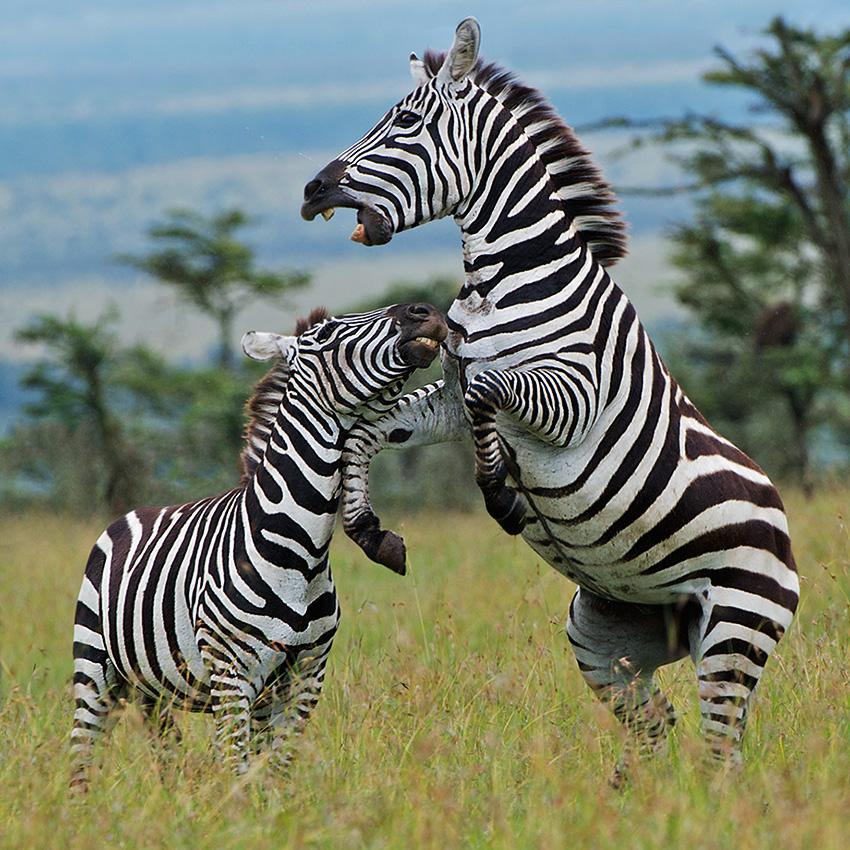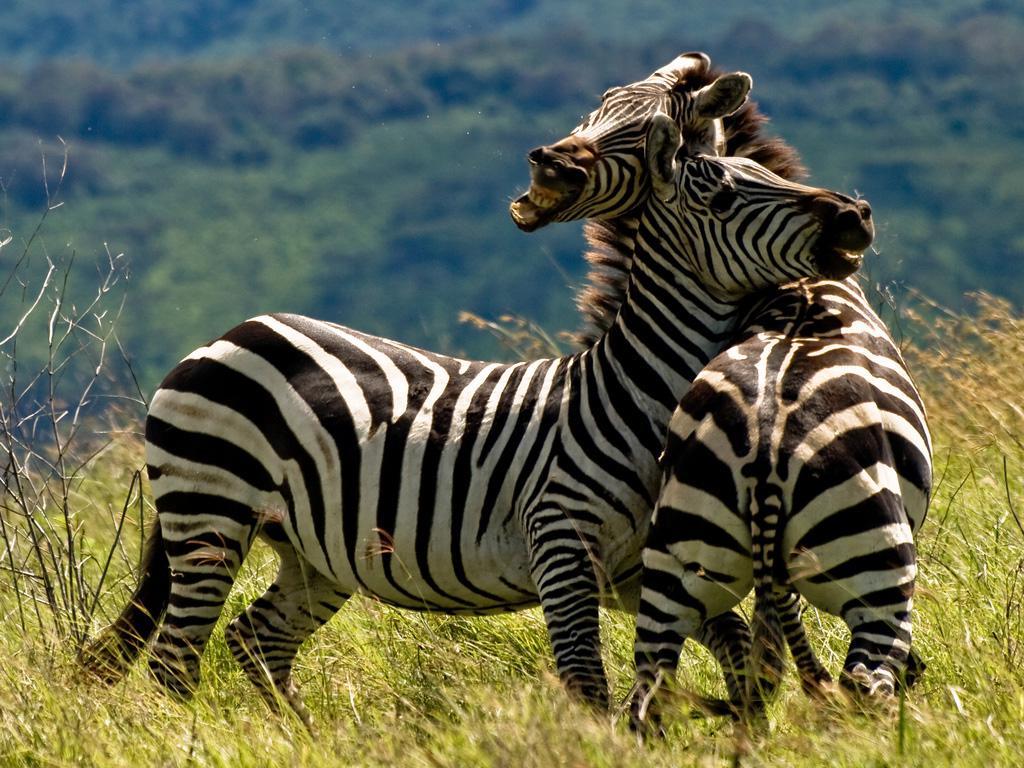The first image is the image on the left, the second image is the image on the right. Given the left and right images, does the statement "Both images show zebras fighting, though one has only two zebras and the other image has more." hold true? Answer yes or no. No. The first image is the image on the left, the second image is the image on the right. Given the left and right images, does the statement "In exactly one of the images there is at least one zebra with its front legs off the ground." hold true? Answer yes or no. Yes. 